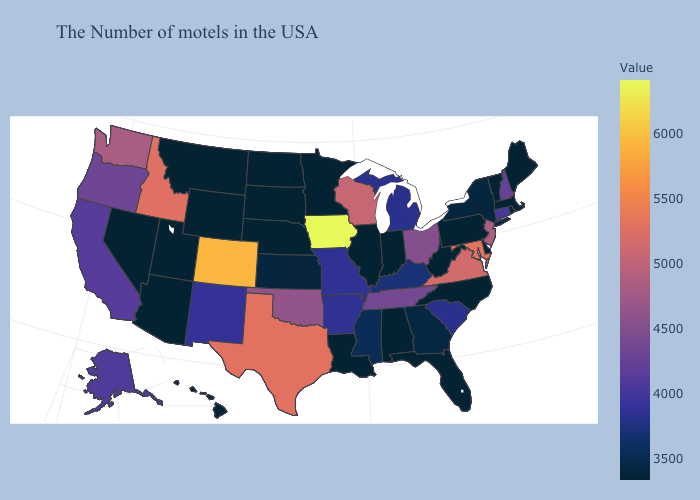Among the states that border Louisiana , does Texas have the highest value?
Keep it brief. Yes. Which states have the lowest value in the South?
Short answer required. Delaware, North Carolina, West Virginia, Florida, Alabama, Louisiana. Does Tennessee have the highest value in the USA?
Short answer required. No. Among the states that border Missouri , does Illinois have the lowest value?
Write a very short answer. Yes. Does Iowa have the highest value in the MidWest?
Answer briefly. Yes. 